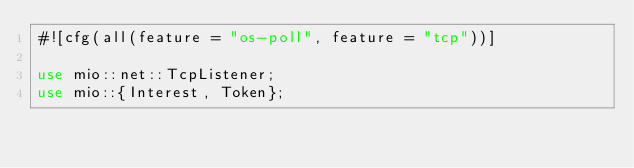<code> <loc_0><loc_0><loc_500><loc_500><_Rust_>#![cfg(all(feature = "os-poll", feature = "tcp"))]

use mio::net::TcpListener;
use mio::{Interest, Token};</code> 